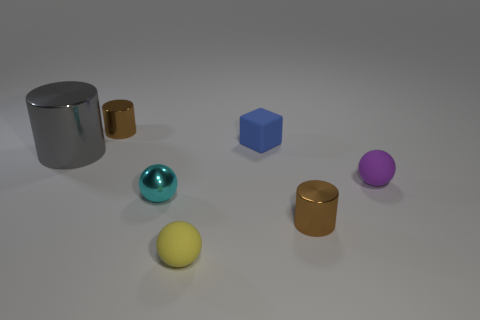What material is the yellow thing?
Offer a very short reply. Rubber. The block that is the same size as the cyan sphere is what color?
Offer a very short reply. Blue. Is the shape of the blue rubber object the same as the big object?
Offer a terse response. No. There is a object that is both left of the tiny blue rubber block and in front of the small cyan metal sphere; what is its material?
Provide a short and direct response. Rubber. The cyan thing has what size?
Make the answer very short. Small. There is another small matte object that is the same shape as the purple thing; what color is it?
Keep it short and to the point. Yellow. Are there any other things that have the same color as the matte cube?
Your response must be concise. No. Is the size of the brown object behind the small metallic sphere the same as the metallic cylinder in front of the small purple matte ball?
Your answer should be very brief. Yes. Are there an equal number of brown shiny cylinders in front of the gray metal object and blue matte objects on the right side of the small cyan thing?
Provide a succinct answer. Yes. There is a gray shiny cylinder; is it the same size as the brown metal cylinder to the left of the cyan object?
Ensure brevity in your answer.  No. 